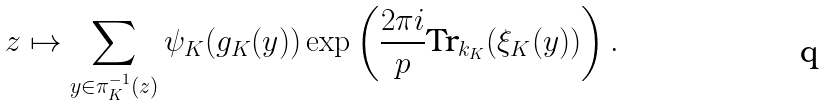<formula> <loc_0><loc_0><loc_500><loc_500>z \mapsto \sum _ { y \in \pi _ { K } ^ { - 1 } ( z ) } \psi _ { K } ( g _ { K } ( y ) ) \exp \left ( \frac { 2 \pi i } { p } \text {Tr} _ { k _ { K } } ( \xi _ { K } ( y ) ) \right ) .</formula> 